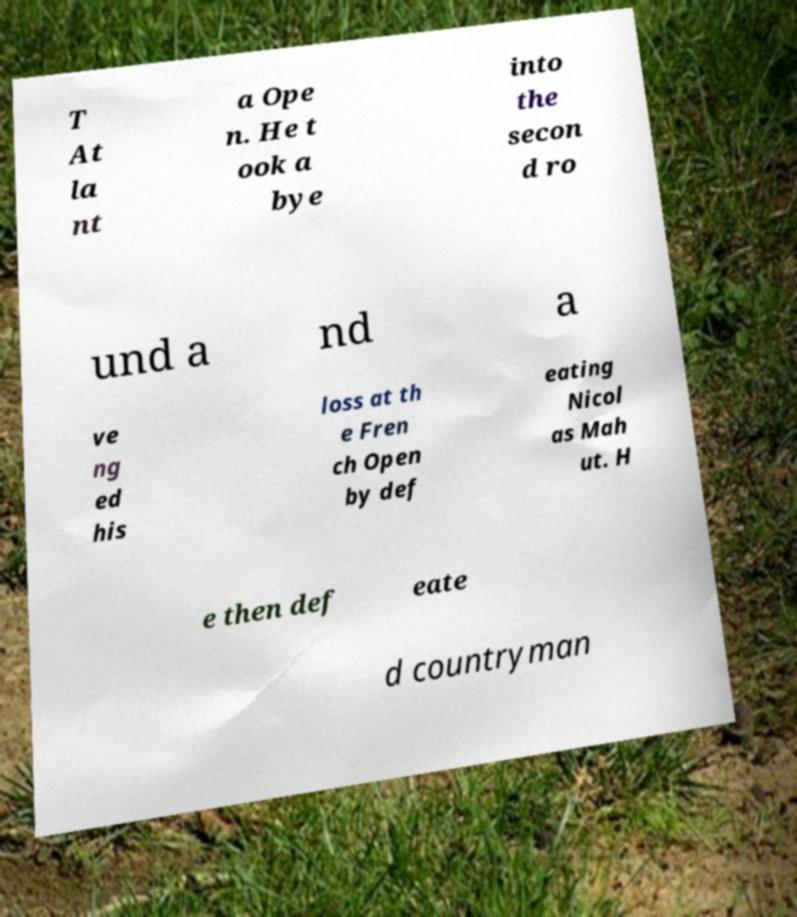Could you assist in decoding the text presented in this image and type it out clearly? T At la nt a Ope n. He t ook a bye into the secon d ro und a nd a ve ng ed his loss at th e Fren ch Open by def eating Nicol as Mah ut. H e then def eate d countryman 